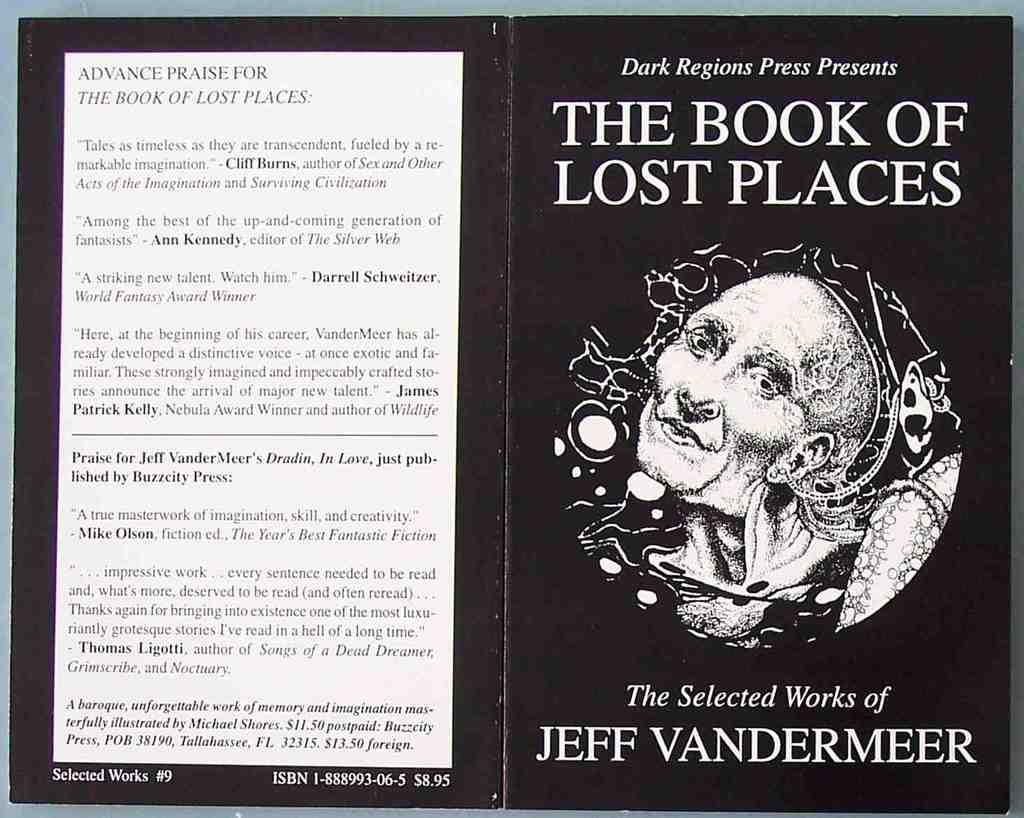<image>
Write a terse but informative summary of the picture. A book by Jeff Vandermeer called "The Book of Lost Places" has a black cover with a face on it. 